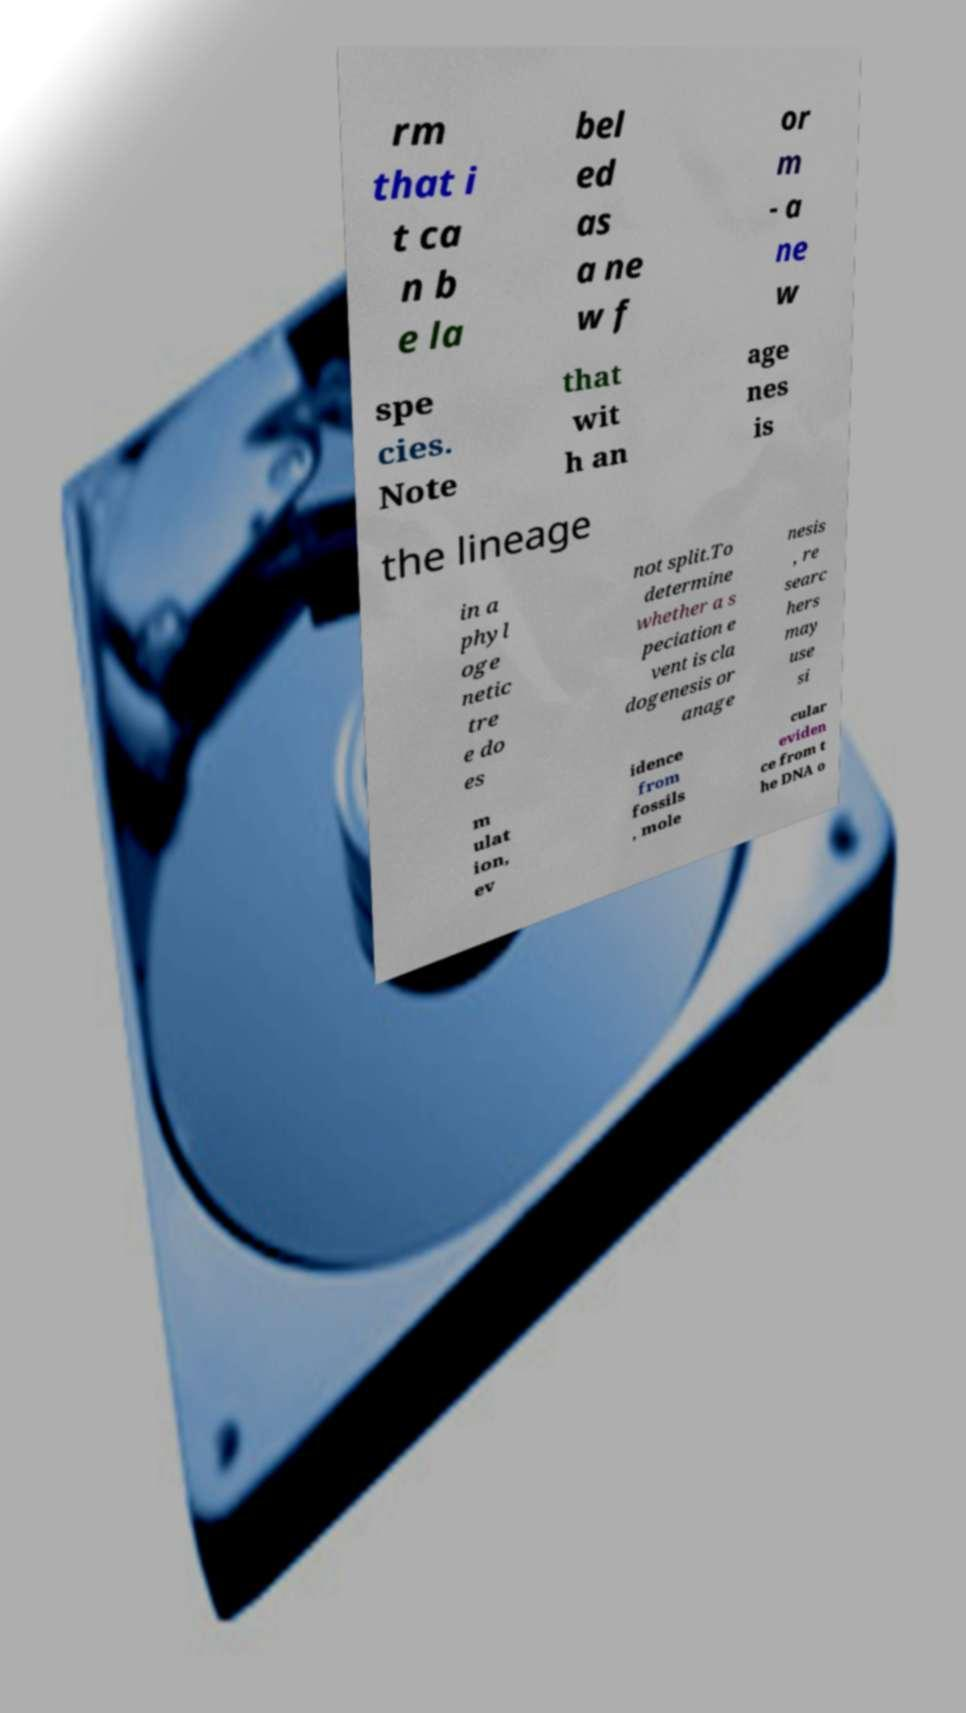Can you read and provide the text displayed in the image?This photo seems to have some interesting text. Can you extract and type it out for me? rm that i t ca n b e la bel ed as a ne w f or m - a ne w spe cies. Note that wit h an age nes is the lineage in a phyl oge netic tre e do es not split.To determine whether a s peciation e vent is cla dogenesis or anage nesis , re searc hers may use si m ulat ion, ev idence from fossils , mole cular eviden ce from t he DNA o 